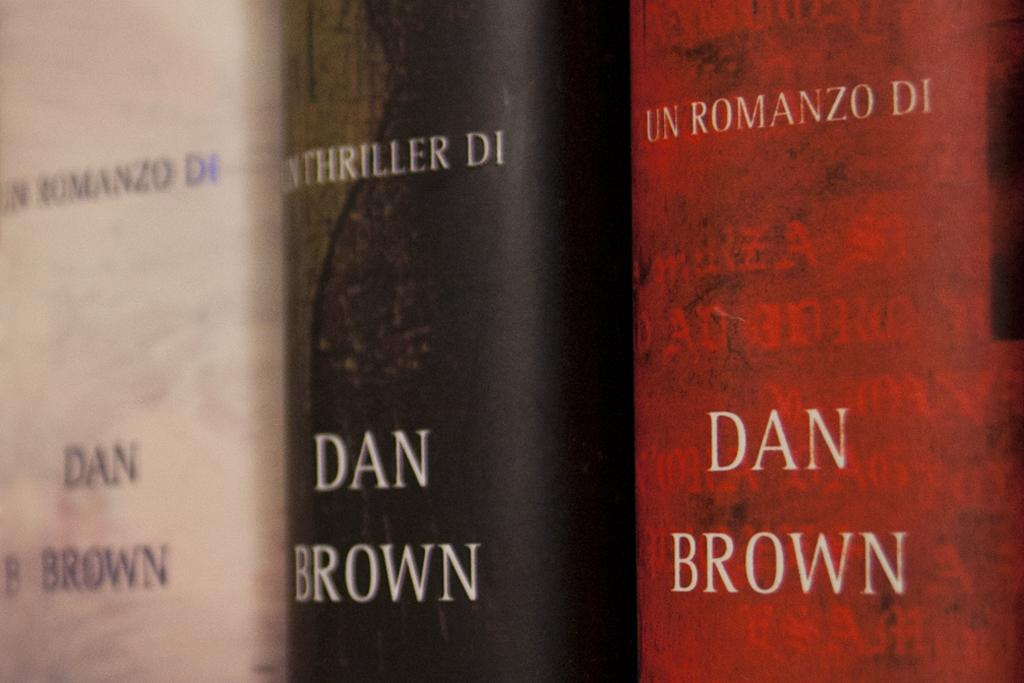<image>
Summarize the visual content of the image. Three Dan Brown books in white black and red. 